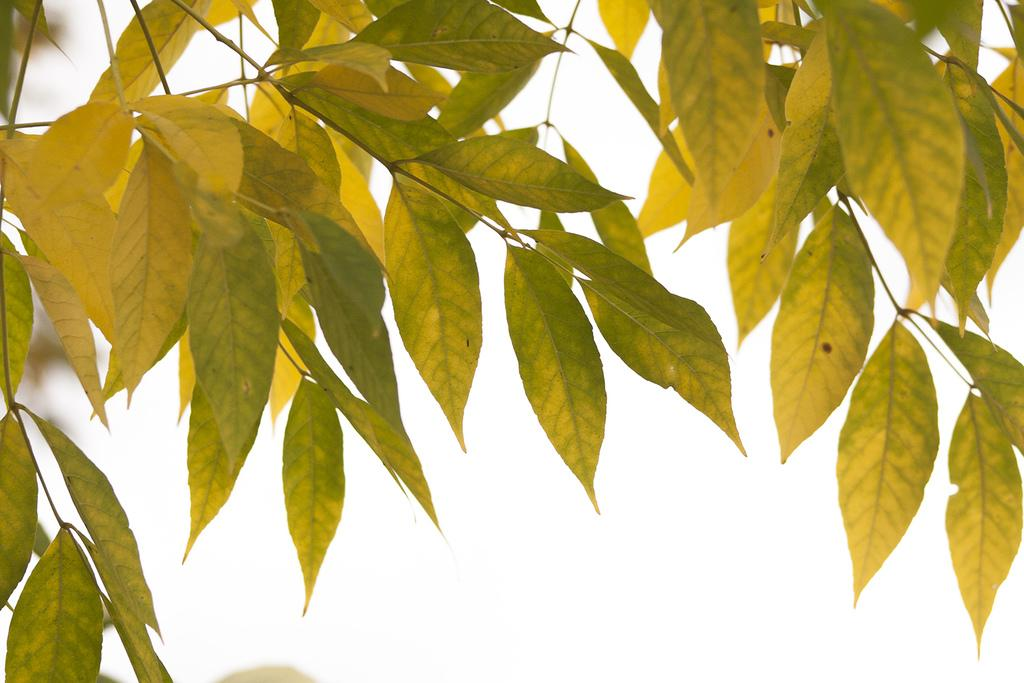What type of vegetation is present in the image? The image contains green leaves. Can you describe the background of the image? The background of the image is blurred. How many grapes are hanging from the net in the image? There is no net or grapes present in the image; it only contains green leaves. 